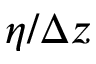<formula> <loc_0><loc_0><loc_500><loc_500>\eta / \Delta z</formula> 